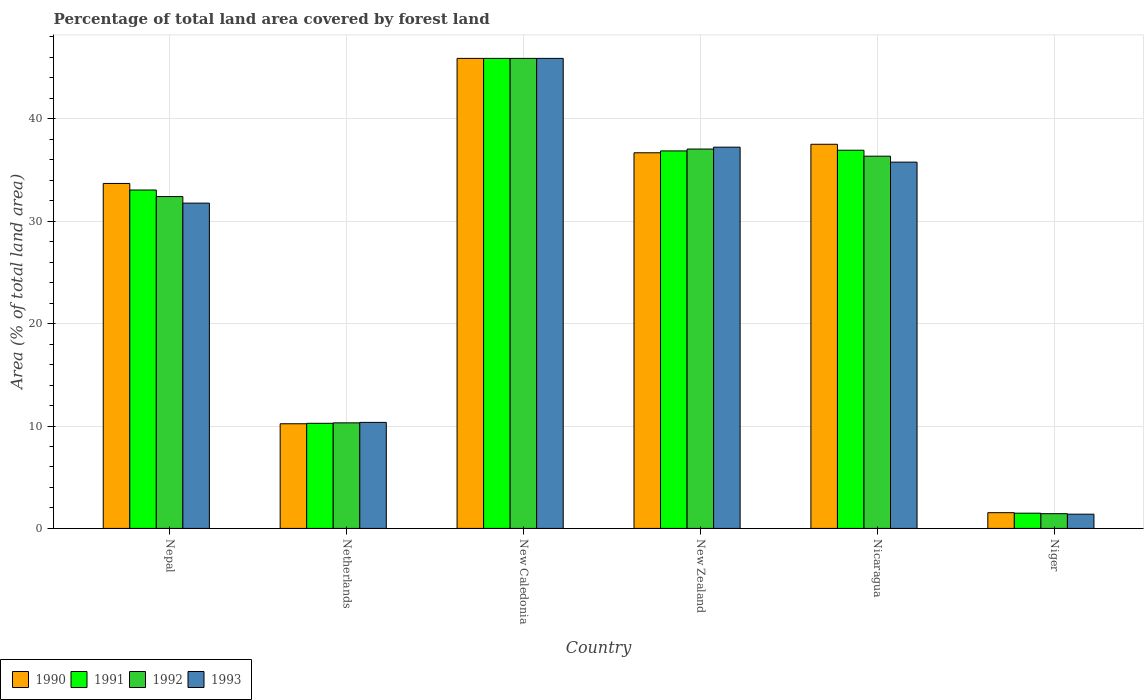How many different coloured bars are there?
Give a very brief answer. 4. How many groups of bars are there?
Offer a very short reply. 6. Are the number of bars on each tick of the X-axis equal?
Offer a terse response. Yes. How many bars are there on the 5th tick from the right?
Offer a terse response. 4. What is the label of the 4th group of bars from the left?
Provide a short and direct response. New Zealand. What is the percentage of forest land in 1993 in Nepal?
Your response must be concise. 31.76. Across all countries, what is the maximum percentage of forest land in 1992?
Your answer should be very brief. 45.9. Across all countries, what is the minimum percentage of forest land in 1992?
Offer a terse response. 1.44. In which country was the percentage of forest land in 1992 maximum?
Make the answer very short. New Caledonia. In which country was the percentage of forest land in 1990 minimum?
Your response must be concise. Niger. What is the total percentage of forest land in 1992 in the graph?
Keep it short and to the point. 163.44. What is the difference between the percentage of forest land in 1991 in Netherlands and that in New Caledonia?
Provide a succinct answer. -35.63. What is the difference between the percentage of forest land in 1990 in Nepal and the percentage of forest land in 1992 in New Caledonia?
Offer a terse response. -12.21. What is the average percentage of forest land in 1992 per country?
Ensure brevity in your answer.  27.24. What is the ratio of the percentage of forest land in 1990 in Netherlands to that in Niger?
Keep it short and to the point. 6.66. Is the percentage of forest land in 1991 in New Zealand less than that in Nicaragua?
Offer a terse response. Yes. Is the difference between the percentage of forest land in 1991 in Nepal and New Zealand greater than the difference between the percentage of forest land in 1993 in Nepal and New Zealand?
Keep it short and to the point. Yes. What is the difference between the highest and the second highest percentage of forest land in 1991?
Your answer should be very brief. -8.97. What is the difference between the highest and the lowest percentage of forest land in 1990?
Make the answer very short. 44.36. Is the sum of the percentage of forest land in 1992 in New Caledonia and Niger greater than the maximum percentage of forest land in 1993 across all countries?
Provide a succinct answer. Yes. Is it the case that in every country, the sum of the percentage of forest land in 1991 and percentage of forest land in 1990 is greater than the sum of percentage of forest land in 1993 and percentage of forest land in 1992?
Make the answer very short. No. What does the 2nd bar from the right in New Zealand represents?
Your answer should be compact. 1992. Is it the case that in every country, the sum of the percentage of forest land in 1992 and percentage of forest land in 1991 is greater than the percentage of forest land in 1990?
Keep it short and to the point. Yes. Are all the bars in the graph horizontal?
Your answer should be compact. No. How many countries are there in the graph?
Ensure brevity in your answer.  6. How are the legend labels stacked?
Offer a terse response. Horizontal. What is the title of the graph?
Provide a succinct answer. Percentage of total land area covered by forest land. Does "1962" appear as one of the legend labels in the graph?
Ensure brevity in your answer.  No. What is the label or title of the X-axis?
Provide a short and direct response. Country. What is the label or title of the Y-axis?
Provide a succinct answer. Area (% of total land area). What is the Area (% of total land area) of 1990 in Nepal?
Offer a terse response. 33.69. What is the Area (% of total land area) of 1991 in Nepal?
Your answer should be very brief. 33.04. What is the Area (% of total land area) in 1992 in Nepal?
Offer a terse response. 32.4. What is the Area (% of total land area) of 1993 in Nepal?
Provide a short and direct response. 31.76. What is the Area (% of total land area) in 1990 in Netherlands?
Keep it short and to the point. 10.22. What is the Area (% of total land area) of 1991 in Netherlands?
Give a very brief answer. 10.26. What is the Area (% of total land area) of 1992 in Netherlands?
Provide a short and direct response. 10.31. What is the Area (% of total land area) of 1993 in Netherlands?
Provide a succinct answer. 10.35. What is the Area (% of total land area) in 1990 in New Caledonia?
Provide a short and direct response. 45.9. What is the Area (% of total land area) in 1991 in New Caledonia?
Offer a very short reply. 45.9. What is the Area (% of total land area) in 1992 in New Caledonia?
Ensure brevity in your answer.  45.9. What is the Area (% of total land area) in 1993 in New Caledonia?
Your response must be concise. 45.9. What is the Area (% of total land area) of 1990 in New Zealand?
Offer a very short reply. 36.68. What is the Area (% of total land area) of 1991 in New Zealand?
Your answer should be compact. 36.86. What is the Area (% of total land area) in 1992 in New Zealand?
Offer a terse response. 37.04. What is the Area (% of total land area) of 1993 in New Zealand?
Your response must be concise. 37.23. What is the Area (% of total land area) in 1990 in Nicaragua?
Offer a terse response. 37.51. What is the Area (% of total land area) of 1991 in Nicaragua?
Ensure brevity in your answer.  36.93. What is the Area (% of total land area) of 1992 in Nicaragua?
Give a very brief answer. 36.35. What is the Area (% of total land area) of 1993 in Nicaragua?
Keep it short and to the point. 35.77. What is the Area (% of total land area) of 1990 in Niger?
Your answer should be compact. 1.54. What is the Area (% of total land area) of 1991 in Niger?
Offer a terse response. 1.49. What is the Area (% of total land area) in 1992 in Niger?
Provide a succinct answer. 1.44. What is the Area (% of total land area) of 1993 in Niger?
Your answer should be very brief. 1.39. Across all countries, what is the maximum Area (% of total land area) of 1990?
Give a very brief answer. 45.9. Across all countries, what is the maximum Area (% of total land area) of 1991?
Offer a terse response. 45.9. Across all countries, what is the maximum Area (% of total land area) of 1992?
Keep it short and to the point. 45.9. Across all countries, what is the maximum Area (% of total land area) in 1993?
Your response must be concise. 45.9. Across all countries, what is the minimum Area (% of total land area) of 1990?
Offer a very short reply. 1.54. Across all countries, what is the minimum Area (% of total land area) in 1991?
Keep it short and to the point. 1.49. Across all countries, what is the minimum Area (% of total land area) in 1992?
Make the answer very short. 1.44. Across all countries, what is the minimum Area (% of total land area) in 1993?
Provide a short and direct response. 1.39. What is the total Area (% of total land area) in 1990 in the graph?
Offer a very short reply. 165.53. What is the total Area (% of total land area) in 1991 in the graph?
Your answer should be very brief. 164.48. What is the total Area (% of total land area) in 1992 in the graph?
Give a very brief answer. 163.44. What is the total Area (% of total land area) of 1993 in the graph?
Your answer should be compact. 162.39. What is the difference between the Area (% of total land area) of 1990 in Nepal and that in Netherlands?
Offer a very short reply. 23.47. What is the difference between the Area (% of total land area) in 1991 in Nepal and that in Netherlands?
Provide a succinct answer. 22.78. What is the difference between the Area (% of total land area) of 1992 in Nepal and that in Netherlands?
Provide a short and direct response. 22.09. What is the difference between the Area (% of total land area) of 1993 in Nepal and that in Netherlands?
Offer a very short reply. 21.41. What is the difference between the Area (% of total land area) in 1990 in Nepal and that in New Caledonia?
Your answer should be very brief. -12.21. What is the difference between the Area (% of total land area) in 1991 in Nepal and that in New Caledonia?
Your response must be concise. -12.85. What is the difference between the Area (% of total land area) in 1992 in Nepal and that in New Caledonia?
Give a very brief answer. -13.49. What is the difference between the Area (% of total land area) of 1993 in Nepal and that in New Caledonia?
Provide a short and direct response. -14.14. What is the difference between the Area (% of total land area) of 1990 in Nepal and that in New Zealand?
Keep it short and to the point. -2.99. What is the difference between the Area (% of total land area) of 1991 in Nepal and that in New Zealand?
Your answer should be compact. -3.82. What is the difference between the Area (% of total land area) of 1992 in Nepal and that in New Zealand?
Ensure brevity in your answer.  -4.64. What is the difference between the Area (% of total land area) of 1993 in Nepal and that in New Zealand?
Keep it short and to the point. -5.47. What is the difference between the Area (% of total land area) of 1990 in Nepal and that in Nicaragua?
Ensure brevity in your answer.  -3.83. What is the difference between the Area (% of total land area) in 1991 in Nepal and that in Nicaragua?
Offer a terse response. -3.88. What is the difference between the Area (% of total land area) in 1992 in Nepal and that in Nicaragua?
Your response must be concise. -3.94. What is the difference between the Area (% of total land area) in 1993 in Nepal and that in Nicaragua?
Provide a succinct answer. -4. What is the difference between the Area (% of total land area) of 1990 in Nepal and that in Niger?
Offer a very short reply. 32.15. What is the difference between the Area (% of total land area) of 1991 in Nepal and that in Niger?
Ensure brevity in your answer.  31.56. What is the difference between the Area (% of total land area) in 1992 in Nepal and that in Niger?
Make the answer very short. 30.96. What is the difference between the Area (% of total land area) in 1993 in Nepal and that in Niger?
Make the answer very short. 30.37. What is the difference between the Area (% of total land area) in 1990 in Netherlands and that in New Caledonia?
Offer a very short reply. -35.68. What is the difference between the Area (% of total land area) in 1991 in Netherlands and that in New Caledonia?
Provide a succinct answer. -35.63. What is the difference between the Area (% of total land area) in 1992 in Netherlands and that in New Caledonia?
Your answer should be very brief. -35.59. What is the difference between the Area (% of total land area) in 1993 in Netherlands and that in New Caledonia?
Your response must be concise. -35.54. What is the difference between the Area (% of total land area) of 1990 in Netherlands and that in New Zealand?
Provide a succinct answer. -26.46. What is the difference between the Area (% of total land area) in 1991 in Netherlands and that in New Zealand?
Give a very brief answer. -26.6. What is the difference between the Area (% of total land area) in 1992 in Netherlands and that in New Zealand?
Keep it short and to the point. -26.74. What is the difference between the Area (% of total land area) in 1993 in Netherlands and that in New Zealand?
Ensure brevity in your answer.  -26.87. What is the difference between the Area (% of total land area) in 1990 in Netherlands and that in Nicaragua?
Your response must be concise. -27.29. What is the difference between the Area (% of total land area) in 1991 in Netherlands and that in Nicaragua?
Your answer should be very brief. -26.67. What is the difference between the Area (% of total land area) of 1992 in Netherlands and that in Nicaragua?
Offer a very short reply. -26.04. What is the difference between the Area (% of total land area) in 1993 in Netherlands and that in Nicaragua?
Your response must be concise. -25.41. What is the difference between the Area (% of total land area) in 1990 in Netherlands and that in Niger?
Ensure brevity in your answer.  8.68. What is the difference between the Area (% of total land area) of 1991 in Netherlands and that in Niger?
Offer a terse response. 8.78. What is the difference between the Area (% of total land area) in 1992 in Netherlands and that in Niger?
Ensure brevity in your answer.  8.87. What is the difference between the Area (% of total land area) of 1993 in Netherlands and that in Niger?
Give a very brief answer. 8.96. What is the difference between the Area (% of total land area) of 1990 in New Caledonia and that in New Zealand?
Keep it short and to the point. 9.22. What is the difference between the Area (% of total land area) of 1991 in New Caledonia and that in New Zealand?
Your response must be concise. 9.04. What is the difference between the Area (% of total land area) in 1992 in New Caledonia and that in New Zealand?
Give a very brief answer. 8.85. What is the difference between the Area (% of total land area) in 1993 in New Caledonia and that in New Zealand?
Provide a short and direct response. 8.67. What is the difference between the Area (% of total land area) of 1990 in New Caledonia and that in Nicaragua?
Provide a short and direct response. 8.39. What is the difference between the Area (% of total land area) of 1991 in New Caledonia and that in Nicaragua?
Your answer should be very brief. 8.97. What is the difference between the Area (% of total land area) of 1992 in New Caledonia and that in Nicaragua?
Give a very brief answer. 9.55. What is the difference between the Area (% of total land area) in 1993 in New Caledonia and that in Nicaragua?
Give a very brief answer. 10.13. What is the difference between the Area (% of total land area) in 1990 in New Caledonia and that in Niger?
Ensure brevity in your answer.  44.36. What is the difference between the Area (% of total land area) in 1991 in New Caledonia and that in Niger?
Make the answer very short. 44.41. What is the difference between the Area (% of total land area) in 1992 in New Caledonia and that in Niger?
Ensure brevity in your answer.  44.46. What is the difference between the Area (% of total land area) of 1993 in New Caledonia and that in Niger?
Keep it short and to the point. 44.51. What is the difference between the Area (% of total land area) of 1990 in New Zealand and that in Nicaragua?
Provide a short and direct response. -0.83. What is the difference between the Area (% of total land area) of 1991 in New Zealand and that in Nicaragua?
Ensure brevity in your answer.  -0.07. What is the difference between the Area (% of total land area) of 1992 in New Zealand and that in Nicaragua?
Offer a very short reply. 0.7. What is the difference between the Area (% of total land area) of 1993 in New Zealand and that in Nicaragua?
Give a very brief answer. 1.46. What is the difference between the Area (% of total land area) in 1990 in New Zealand and that in Niger?
Provide a succinct answer. 35.14. What is the difference between the Area (% of total land area) of 1991 in New Zealand and that in Niger?
Your response must be concise. 35.38. What is the difference between the Area (% of total land area) of 1992 in New Zealand and that in Niger?
Offer a terse response. 35.61. What is the difference between the Area (% of total land area) in 1993 in New Zealand and that in Niger?
Give a very brief answer. 35.84. What is the difference between the Area (% of total land area) in 1990 in Nicaragua and that in Niger?
Your answer should be compact. 35.97. What is the difference between the Area (% of total land area) in 1991 in Nicaragua and that in Niger?
Provide a short and direct response. 35.44. What is the difference between the Area (% of total land area) in 1992 in Nicaragua and that in Niger?
Your response must be concise. 34.91. What is the difference between the Area (% of total land area) of 1993 in Nicaragua and that in Niger?
Your answer should be compact. 34.38. What is the difference between the Area (% of total land area) in 1990 in Nepal and the Area (% of total land area) in 1991 in Netherlands?
Offer a very short reply. 23.42. What is the difference between the Area (% of total land area) of 1990 in Nepal and the Area (% of total land area) of 1992 in Netherlands?
Make the answer very short. 23.38. What is the difference between the Area (% of total land area) of 1990 in Nepal and the Area (% of total land area) of 1993 in Netherlands?
Provide a short and direct response. 23.33. What is the difference between the Area (% of total land area) in 1991 in Nepal and the Area (% of total land area) in 1992 in Netherlands?
Keep it short and to the point. 22.74. What is the difference between the Area (% of total land area) in 1991 in Nepal and the Area (% of total land area) in 1993 in Netherlands?
Give a very brief answer. 22.69. What is the difference between the Area (% of total land area) of 1992 in Nepal and the Area (% of total land area) of 1993 in Netherlands?
Ensure brevity in your answer.  22.05. What is the difference between the Area (% of total land area) of 1990 in Nepal and the Area (% of total land area) of 1991 in New Caledonia?
Your answer should be compact. -12.21. What is the difference between the Area (% of total land area) of 1990 in Nepal and the Area (% of total land area) of 1992 in New Caledonia?
Give a very brief answer. -12.21. What is the difference between the Area (% of total land area) in 1990 in Nepal and the Area (% of total land area) in 1993 in New Caledonia?
Ensure brevity in your answer.  -12.21. What is the difference between the Area (% of total land area) in 1991 in Nepal and the Area (% of total land area) in 1992 in New Caledonia?
Your answer should be very brief. -12.85. What is the difference between the Area (% of total land area) in 1991 in Nepal and the Area (% of total land area) in 1993 in New Caledonia?
Make the answer very short. -12.85. What is the difference between the Area (% of total land area) of 1992 in Nepal and the Area (% of total land area) of 1993 in New Caledonia?
Your answer should be very brief. -13.49. What is the difference between the Area (% of total land area) in 1990 in Nepal and the Area (% of total land area) in 1991 in New Zealand?
Make the answer very short. -3.18. What is the difference between the Area (% of total land area) in 1990 in Nepal and the Area (% of total land area) in 1992 in New Zealand?
Give a very brief answer. -3.36. What is the difference between the Area (% of total land area) of 1990 in Nepal and the Area (% of total land area) of 1993 in New Zealand?
Provide a short and direct response. -3.54. What is the difference between the Area (% of total land area) of 1991 in Nepal and the Area (% of total land area) of 1992 in New Zealand?
Your answer should be very brief. -4. What is the difference between the Area (% of total land area) of 1991 in Nepal and the Area (% of total land area) of 1993 in New Zealand?
Offer a very short reply. -4.18. What is the difference between the Area (% of total land area) of 1992 in Nepal and the Area (% of total land area) of 1993 in New Zealand?
Give a very brief answer. -4.82. What is the difference between the Area (% of total land area) in 1990 in Nepal and the Area (% of total land area) in 1991 in Nicaragua?
Make the answer very short. -3.24. What is the difference between the Area (% of total land area) in 1990 in Nepal and the Area (% of total land area) in 1992 in Nicaragua?
Give a very brief answer. -2.66. What is the difference between the Area (% of total land area) in 1990 in Nepal and the Area (% of total land area) in 1993 in Nicaragua?
Make the answer very short. -2.08. What is the difference between the Area (% of total land area) of 1991 in Nepal and the Area (% of total land area) of 1992 in Nicaragua?
Offer a very short reply. -3.3. What is the difference between the Area (% of total land area) of 1991 in Nepal and the Area (% of total land area) of 1993 in Nicaragua?
Give a very brief answer. -2.72. What is the difference between the Area (% of total land area) in 1992 in Nepal and the Area (% of total land area) in 1993 in Nicaragua?
Offer a terse response. -3.36. What is the difference between the Area (% of total land area) of 1990 in Nepal and the Area (% of total land area) of 1991 in Niger?
Your response must be concise. 32.2. What is the difference between the Area (% of total land area) of 1990 in Nepal and the Area (% of total land area) of 1992 in Niger?
Give a very brief answer. 32.25. What is the difference between the Area (% of total land area) of 1990 in Nepal and the Area (% of total land area) of 1993 in Niger?
Make the answer very short. 32.3. What is the difference between the Area (% of total land area) of 1991 in Nepal and the Area (% of total land area) of 1992 in Niger?
Ensure brevity in your answer.  31.61. What is the difference between the Area (% of total land area) of 1991 in Nepal and the Area (% of total land area) of 1993 in Niger?
Provide a short and direct response. 31.65. What is the difference between the Area (% of total land area) in 1992 in Nepal and the Area (% of total land area) in 1993 in Niger?
Provide a short and direct response. 31.01. What is the difference between the Area (% of total land area) of 1990 in Netherlands and the Area (% of total land area) of 1991 in New Caledonia?
Keep it short and to the point. -35.68. What is the difference between the Area (% of total land area) in 1990 in Netherlands and the Area (% of total land area) in 1992 in New Caledonia?
Offer a very short reply. -35.68. What is the difference between the Area (% of total land area) in 1990 in Netherlands and the Area (% of total land area) in 1993 in New Caledonia?
Your answer should be very brief. -35.68. What is the difference between the Area (% of total land area) of 1991 in Netherlands and the Area (% of total land area) of 1992 in New Caledonia?
Your answer should be compact. -35.63. What is the difference between the Area (% of total land area) of 1991 in Netherlands and the Area (% of total land area) of 1993 in New Caledonia?
Offer a very short reply. -35.63. What is the difference between the Area (% of total land area) of 1992 in Netherlands and the Area (% of total land area) of 1993 in New Caledonia?
Provide a short and direct response. -35.59. What is the difference between the Area (% of total land area) of 1990 in Netherlands and the Area (% of total land area) of 1991 in New Zealand?
Your response must be concise. -26.64. What is the difference between the Area (% of total land area) of 1990 in Netherlands and the Area (% of total land area) of 1992 in New Zealand?
Ensure brevity in your answer.  -26.83. What is the difference between the Area (% of total land area) in 1990 in Netherlands and the Area (% of total land area) in 1993 in New Zealand?
Keep it short and to the point. -27.01. What is the difference between the Area (% of total land area) in 1991 in Netherlands and the Area (% of total land area) in 1992 in New Zealand?
Keep it short and to the point. -26.78. What is the difference between the Area (% of total land area) in 1991 in Netherlands and the Area (% of total land area) in 1993 in New Zealand?
Offer a very short reply. -26.96. What is the difference between the Area (% of total land area) of 1992 in Netherlands and the Area (% of total land area) of 1993 in New Zealand?
Keep it short and to the point. -26.92. What is the difference between the Area (% of total land area) in 1990 in Netherlands and the Area (% of total land area) in 1991 in Nicaragua?
Your response must be concise. -26.71. What is the difference between the Area (% of total land area) in 1990 in Netherlands and the Area (% of total land area) in 1992 in Nicaragua?
Provide a short and direct response. -26.13. What is the difference between the Area (% of total land area) of 1990 in Netherlands and the Area (% of total land area) of 1993 in Nicaragua?
Give a very brief answer. -25.55. What is the difference between the Area (% of total land area) in 1991 in Netherlands and the Area (% of total land area) in 1992 in Nicaragua?
Offer a terse response. -26.08. What is the difference between the Area (% of total land area) of 1991 in Netherlands and the Area (% of total land area) of 1993 in Nicaragua?
Provide a short and direct response. -25.5. What is the difference between the Area (% of total land area) of 1992 in Netherlands and the Area (% of total land area) of 1993 in Nicaragua?
Make the answer very short. -25.46. What is the difference between the Area (% of total land area) of 1990 in Netherlands and the Area (% of total land area) of 1991 in Niger?
Your answer should be very brief. 8.73. What is the difference between the Area (% of total land area) of 1990 in Netherlands and the Area (% of total land area) of 1992 in Niger?
Provide a short and direct response. 8.78. What is the difference between the Area (% of total land area) in 1990 in Netherlands and the Area (% of total land area) in 1993 in Niger?
Give a very brief answer. 8.83. What is the difference between the Area (% of total land area) in 1991 in Netherlands and the Area (% of total land area) in 1992 in Niger?
Your answer should be compact. 8.83. What is the difference between the Area (% of total land area) in 1991 in Netherlands and the Area (% of total land area) in 1993 in Niger?
Offer a terse response. 8.87. What is the difference between the Area (% of total land area) of 1992 in Netherlands and the Area (% of total land area) of 1993 in Niger?
Your answer should be compact. 8.92. What is the difference between the Area (% of total land area) of 1990 in New Caledonia and the Area (% of total land area) of 1991 in New Zealand?
Your answer should be very brief. 9.04. What is the difference between the Area (% of total land area) in 1990 in New Caledonia and the Area (% of total land area) in 1992 in New Zealand?
Offer a very short reply. 8.85. What is the difference between the Area (% of total land area) of 1990 in New Caledonia and the Area (% of total land area) of 1993 in New Zealand?
Your answer should be compact. 8.67. What is the difference between the Area (% of total land area) in 1991 in New Caledonia and the Area (% of total land area) in 1992 in New Zealand?
Provide a succinct answer. 8.85. What is the difference between the Area (% of total land area) in 1991 in New Caledonia and the Area (% of total land area) in 1993 in New Zealand?
Your response must be concise. 8.67. What is the difference between the Area (% of total land area) of 1992 in New Caledonia and the Area (% of total land area) of 1993 in New Zealand?
Give a very brief answer. 8.67. What is the difference between the Area (% of total land area) in 1990 in New Caledonia and the Area (% of total land area) in 1991 in Nicaragua?
Ensure brevity in your answer.  8.97. What is the difference between the Area (% of total land area) in 1990 in New Caledonia and the Area (% of total land area) in 1992 in Nicaragua?
Your answer should be compact. 9.55. What is the difference between the Area (% of total land area) of 1990 in New Caledonia and the Area (% of total land area) of 1993 in Nicaragua?
Your response must be concise. 10.13. What is the difference between the Area (% of total land area) of 1991 in New Caledonia and the Area (% of total land area) of 1992 in Nicaragua?
Provide a succinct answer. 9.55. What is the difference between the Area (% of total land area) in 1991 in New Caledonia and the Area (% of total land area) in 1993 in Nicaragua?
Offer a very short reply. 10.13. What is the difference between the Area (% of total land area) of 1992 in New Caledonia and the Area (% of total land area) of 1993 in Nicaragua?
Your answer should be compact. 10.13. What is the difference between the Area (% of total land area) in 1990 in New Caledonia and the Area (% of total land area) in 1991 in Niger?
Give a very brief answer. 44.41. What is the difference between the Area (% of total land area) in 1990 in New Caledonia and the Area (% of total land area) in 1992 in Niger?
Offer a very short reply. 44.46. What is the difference between the Area (% of total land area) in 1990 in New Caledonia and the Area (% of total land area) in 1993 in Niger?
Offer a very short reply. 44.51. What is the difference between the Area (% of total land area) in 1991 in New Caledonia and the Area (% of total land area) in 1992 in Niger?
Your answer should be very brief. 44.46. What is the difference between the Area (% of total land area) in 1991 in New Caledonia and the Area (% of total land area) in 1993 in Niger?
Give a very brief answer. 44.51. What is the difference between the Area (% of total land area) of 1992 in New Caledonia and the Area (% of total land area) of 1993 in Niger?
Your answer should be very brief. 44.51. What is the difference between the Area (% of total land area) of 1990 in New Zealand and the Area (% of total land area) of 1991 in Nicaragua?
Give a very brief answer. -0.25. What is the difference between the Area (% of total land area) of 1990 in New Zealand and the Area (% of total land area) of 1992 in Nicaragua?
Your response must be concise. 0.33. What is the difference between the Area (% of total land area) in 1990 in New Zealand and the Area (% of total land area) in 1993 in Nicaragua?
Ensure brevity in your answer.  0.91. What is the difference between the Area (% of total land area) of 1991 in New Zealand and the Area (% of total land area) of 1992 in Nicaragua?
Make the answer very short. 0.51. What is the difference between the Area (% of total land area) of 1991 in New Zealand and the Area (% of total land area) of 1993 in Nicaragua?
Provide a succinct answer. 1.1. What is the difference between the Area (% of total land area) in 1992 in New Zealand and the Area (% of total land area) in 1993 in Nicaragua?
Ensure brevity in your answer.  1.28. What is the difference between the Area (% of total land area) of 1990 in New Zealand and the Area (% of total land area) of 1991 in Niger?
Ensure brevity in your answer.  35.19. What is the difference between the Area (% of total land area) of 1990 in New Zealand and the Area (% of total land area) of 1992 in Niger?
Give a very brief answer. 35.24. What is the difference between the Area (% of total land area) in 1990 in New Zealand and the Area (% of total land area) in 1993 in Niger?
Keep it short and to the point. 35.29. What is the difference between the Area (% of total land area) in 1991 in New Zealand and the Area (% of total land area) in 1992 in Niger?
Provide a succinct answer. 35.42. What is the difference between the Area (% of total land area) in 1991 in New Zealand and the Area (% of total land area) in 1993 in Niger?
Provide a short and direct response. 35.47. What is the difference between the Area (% of total land area) in 1992 in New Zealand and the Area (% of total land area) in 1993 in Niger?
Provide a succinct answer. 35.66. What is the difference between the Area (% of total land area) of 1990 in Nicaragua and the Area (% of total land area) of 1991 in Niger?
Your answer should be compact. 36.02. What is the difference between the Area (% of total land area) of 1990 in Nicaragua and the Area (% of total land area) of 1992 in Niger?
Your answer should be very brief. 36.07. What is the difference between the Area (% of total land area) of 1990 in Nicaragua and the Area (% of total land area) of 1993 in Niger?
Offer a very short reply. 36.12. What is the difference between the Area (% of total land area) in 1991 in Nicaragua and the Area (% of total land area) in 1992 in Niger?
Make the answer very short. 35.49. What is the difference between the Area (% of total land area) in 1991 in Nicaragua and the Area (% of total land area) in 1993 in Niger?
Your response must be concise. 35.54. What is the difference between the Area (% of total land area) of 1992 in Nicaragua and the Area (% of total land area) of 1993 in Niger?
Your answer should be very brief. 34.96. What is the average Area (% of total land area) of 1990 per country?
Your answer should be compact. 27.59. What is the average Area (% of total land area) in 1991 per country?
Provide a succinct answer. 27.41. What is the average Area (% of total land area) of 1992 per country?
Your response must be concise. 27.24. What is the average Area (% of total land area) of 1993 per country?
Your answer should be compact. 27.07. What is the difference between the Area (% of total land area) of 1990 and Area (% of total land area) of 1991 in Nepal?
Provide a succinct answer. 0.64. What is the difference between the Area (% of total land area) of 1990 and Area (% of total land area) of 1992 in Nepal?
Provide a short and direct response. 1.28. What is the difference between the Area (% of total land area) in 1990 and Area (% of total land area) in 1993 in Nepal?
Give a very brief answer. 1.92. What is the difference between the Area (% of total land area) of 1991 and Area (% of total land area) of 1992 in Nepal?
Make the answer very short. 0.64. What is the difference between the Area (% of total land area) in 1991 and Area (% of total land area) in 1993 in Nepal?
Your answer should be very brief. 1.28. What is the difference between the Area (% of total land area) in 1992 and Area (% of total land area) in 1993 in Nepal?
Provide a succinct answer. 0.64. What is the difference between the Area (% of total land area) in 1990 and Area (% of total land area) in 1991 in Netherlands?
Keep it short and to the point. -0.04. What is the difference between the Area (% of total land area) in 1990 and Area (% of total land area) in 1992 in Netherlands?
Provide a short and direct response. -0.09. What is the difference between the Area (% of total land area) in 1990 and Area (% of total land area) in 1993 in Netherlands?
Give a very brief answer. -0.13. What is the difference between the Area (% of total land area) of 1991 and Area (% of total land area) of 1992 in Netherlands?
Ensure brevity in your answer.  -0.04. What is the difference between the Area (% of total land area) in 1991 and Area (% of total land area) in 1993 in Netherlands?
Make the answer very short. -0.09. What is the difference between the Area (% of total land area) in 1992 and Area (% of total land area) in 1993 in Netherlands?
Your answer should be very brief. -0.04. What is the difference between the Area (% of total land area) of 1990 and Area (% of total land area) of 1992 in New Caledonia?
Give a very brief answer. 0. What is the difference between the Area (% of total land area) of 1990 and Area (% of total land area) of 1993 in New Caledonia?
Your response must be concise. 0. What is the difference between the Area (% of total land area) in 1991 and Area (% of total land area) in 1992 in New Caledonia?
Keep it short and to the point. 0. What is the difference between the Area (% of total land area) of 1991 and Area (% of total land area) of 1993 in New Caledonia?
Offer a very short reply. 0. What is the difference between the Area (% of total land area) in 1992 and Area (% of total land area) in 1993 in New Caledonia?
Provide a short and direct response. 0. What is the difference between the Area (% of total land area) in 1990 and Area (% of total land area) in 1991 in New Zealand?
Your response must be concise. -0.18. What is the difference between the Area (% of total land area) in 1990 and Area (% of total land area) in 1992 in New Zealand?
Offer a terse response. -0.37. What is the difference between the Area (% of total land area) of 1990 and Area (% of total land area) of 1993 in New Zealand?
Keep it short and to the point. -0.55. What is the difference between the Area (% of total land area) of 1991 and Area (% of total land area) of 1992 in New Zealand?
Offer a terse response. -0.18. What is the difference between the Area (% of total land area) in 1991 and Area (% of total land area) in 1993 in New Zealand?
Provide a short and direct response. -0.37. What is the difference between the Area (% of total land area) of 1992 and Area (% of total land area) of 1993 in New Zealand?
Offer a very short reply. -0.18. What is the difference between the Area (% of total land area) of 1990 and Area (% of total land area) of 1991 in Nicaragua?
Provide a succinct answer. 0.58. What is the difference between the Area (% of total land area) of 1990 and Area (% of total land area) of 1992 in Nicaragua?
Provide a short and direct response. 1.16. What is the difference between the Area (% of total land area) of 1990 and Area (% of total land area) of 1993 in Nicaragua?
Keep it short and to the point. 1.75. What is the difference between the Area (% of total land area) of 1991 and Area (% of total land area) of 1992 in Nicaragua?
Your answer should be very brief. 0.58. What is the difference between the Area (% of total land area) in 1991 and Area (% of total land area) in 1993 in Nicaragua?
Ensure brevity in your answer.  1.16. What is the difference between the Area (% of total land area) of 1992 and Area (% of total land area) of 1993 in Nicaragua?
Your answer should be very brief. 0.58. What is the difference between the Area (% of total land area) of 1990 and Area (% of total land area) of 1991 in Niger?
Your response must be concise. 0.05. What is the difference between the Area (% of total land area) of 1990 and Area (% of total land area) of 1992 in Niger?
Provide a succinct answer. 0.1. What is the difference between the Area (% of total land area) in 1990 and Area (% of total land area) in 1993 in Niger?
Provide a short and direct response. 0.15. What is the difference between the Area (% of total land area) in 1991 and Area (% of total land area) in 1992 in Niger?
Offer a very short reply. 0.05. What is the difference between the Area (% of total land area) of 1991 and Area (% of total land area) of 1993 in Niger?
Your response must be concise. 0.1. What is the difference between the Area (% of total land area) in 1992 and Area (% of total land area) in 1993 in Niger?
Ensure brevity in your answer.  0.05. What is the ratio of the Area (% of total land area) in 1990 in Nepal to that in Netherlands?
Give a very brief answer. 3.3. What is the ratio of the Area (% of total land area) in 1991 in Nepal to that in Netherlands?
Give a very brief answer. 3.22. What is the ratio of the Area (% of total land area) of 1992 in Nepal to that in Netherlands?
Offer a very short reply. 3.14. What is the ratio of the Area (% of total land area) in 1993 in Nepal to that in Netherlands?
Offer a terse response. 3.07. What is the ratio of the Area (% of total land area) in 1990 in Nepal to that in New Caledonia?
Keep it short and to the point. 0.73. What is the ratio of the Area (% of total land area) of 1991 in Nepal to that in New Caledonia?
Your answer should be very brief. 0.72. What is the ratio of the Area (% of total land area) in 1992 in Nepal to that in New Caledonia?
Make the answer very short. 0.71. What is the ratio of the Area (% of total land area) of 1993 in Nepal to that in New Caledonia?
Make the answer very short. 0.69. What is the ratio of the Area (% of total land area) of 1990 in Nepal to that in New Zealand?
Offer a very short reply. 0.92. What is the ratio of the Area (% of total land area) of 1991 in Nepal to that in New Zealand?
Your answer should be very brief. 0.9. What is the ratio of the Area (% of total land area) of 1992 in Nepal to that in New Zealand?
Offer a terse response. 0.87. What is the ratio of the Area (% of total land area) of 1993 in Nepal to that in New Zealand?
Provide a short and direct response. 0.85. What is the ratio of the Area (% of total land area) of 1990 in Nepal to that in Nicaragua?
Offer a very short reply. 0.9. What is the ratio of the Area (% of total land area) in 1991 in Nepal to that in Nicaragua?
Your answer should be very brief. 0.89. What is the ratio of the Area (% of total land area) of 1992 in Nepal to that in Nicaragua?
Offer a terse response. 0.89. What is the ratio of the Area (% of total land area) of 1993 in Nepal to that in Nicaragua?
Keep it short and to the point. 0.89. What is the ratio of the Area (% of total land area) in 1990 in Nepal to that in Niger?
Your answer should be very brief. 21.94. What is the ratio of the Area (% of total land area) of 1991 in Nepal to that in Niger?
Ensure brevity in your answer.  22.23. What is the ratio of the Area (% of total land area) of 1992 in Nepal to that in Niger?
Provide a short and direct response. 22.53. What is the ratio of the Area (% of total land area) of 1993 in Nepal to that in Niger?
Keep it short and to the point. 22.86. What is the ratio of the Area (% of total land area) of 1990 in Netherlands to that in New Caledonia?
Give a very brief answer. 0.22. What is the ratio of the Area (% of total land area) of 1991 in Netherlands to that in New Caledonia?
Provide a short and direct response. 0.22. What is the ratio of the Area (% of total land area) of 1992 in Netherlands to that in New Caledonia?
Your response must be concise. 0.22. What is the ratio of the Area (% of total land area) of 1993 in Netherlands to that in New Caledonia?
Offer a very short reply. 0.23. What is the ratio of the Area (% of total land area) in 1990 in Netherlands to that in New Zealand?
Ensure brevity in your answer.  0.28. What is the ratio of the Area (% of total land area) in 1991 in Netherlands to that in New Zealand?
Ensure brevity in your answer.  0.28. What is the ratio of the Area (% of total land area) in 1992 in Netherlands to that in New Zealand?
Offer a very short reply. 0.28. What is the ratio of the Area (% of total land area) in 1993 in Netherlands to that in New Zealand?
Your answer should be very brief. 0.28. What is the ratio of the Area (% of total land area) of 1990 in Netherlands to that in Nicaragua?
Provide a succinct answer. 0.27. What is the ratio of the Area (% of total land area) in 1991 in Netherlands to that in Nicaragua?
Ensure brevity in your answer.  0.28. What is the ratio of the Area (% of total land area) in 1992 in Netherlands to that in Nicaragua?
Ensure brevity in your answer.  0.28. What is the ratio of the Area (% of total land area) in 1993 in Netherlands to that in Nicaragua?
Give a very brief answer. 0.29. What is the ratio of the Area (% of total land area) of 1990 in Netherlands to that in Niger?
Keep it short and to the point. 6.66. What is the ratio of the Area (% of total land area) of 1991 in Netherlands to that in Niger?
Give a very brief answer. 6.9. What is the ratio of the Area (% of total land area) in 1992 in Netherlands to that in Niger?
Make the answer very short. 7.17. What is the ratio of the Area (% of total land area) in 1993 in Netherlands to that in Niger?
Provide a succinct answer. 7.45. What is the ratio of the Area (% of total land area) in 1990 in New Caledonia to that in New Zealand?
Offer a terse response. 1.25. What is the ratio of the Area (% of total land area) in 1991 in New Caledonia to that in New Zealand?
Make the answer very short. 1.25. What is the ratio of the Area (% of total land area) in 1992 in New Caledonia to that in New Zealand?
Provide a succinct answer. 1.24. What is the ratio of the Area (% of total land area) in 1993 in New Caledonia to that in New Zealand?
Your answer should be compact. 1.23. What is the ratio of the Area (% of total land area) of 1990 in New Caledonia to that in Nicaragua?
Your answer should be compact. 1.22. What is the ratio of the Area (% of total land area) in 1991 in New Caledonia to that in Nicaragua?
Provide a succinct answer. 1.24. What is the ratio of the Area (% of total land area) of 1992 in New Caledonia to that in Nicaragua?
Your answer should be compact. 1.26. What is the ratio of the Area (% of total land area) in 1993 in New Caledonia to that in Nicaragua?
Offer a terse response. 1.28. What is the ratio of the Area (% of total land area) in 1990 in New Caledonia to that in Niger?
Offer a terse response. 29.89. What is the ratio of the Area (% of total land area) in 1991 in New Caledonia to that in Niger?
Your answer should be very brief. 30.87. What is the ratio of the Area (% of total land area) of 1992 in New Caledonia to that in Niger?
Make the answer very short. 31.92. What is the ratio of the Area (% of total land area) of 1993 in New Caledonia to that in Niger?
Provide a succinct answer. 33.03. What is the ratio of the Area (% of total land area) in 1990 in New Zealand to that in Nicaragua?
Ensure brevity in your answer.  0.98. What is the ratio of the Area (% of total land area) in 1992 in New Zealand to that in Nicaragua?
Your answer should be very brief. 1.02. What is the ratio of the Area (% of total land area) in 1993 in New Zealand to that in Nicaragua?
Make the answer very short. 1.04. What is the ratio of the Area (% of total land area) in 1990 in New Zealand to that in Niger?
Provide a succinct answer. 23.89. What is the ratio of the Area (% of total land area) in 1991 in New Zealand to that in Niger?
Ensure brevity in your answer.  24.79. What is the ratio of the Area (% of total land area) in 1992 in New Zealand to that in Niger?
Offer a very short reply. 25.76. What is the ratio of the Area (% of total land area) of 1993 in New Zealand to that in Niger?
Make the answer very short. 26.79. What is the ratio of the Area (% of total land area) of 1990 in Nicaragua to that in Niger?
Keep it short and to the point. 24.43. What is the ratio of the Area (% of total land area) of 1991 in Nicaragua to that in Niger?
Offer a very short reply. 24.84. What is the ratio of the Area (% of total land area) of 1992 in Nicaragua to that in Niger?
Give a very brief answer. 25.27. What is the ratio of the Area (% of total land area) in 1993 in Nicaragua to that in Niger?
Provide a succinct answer. 25.74. What is the difference between the highest and the second highest Area (% of total land area) of 1990?
Your answer should be compact. 8.39. What is the difference between the highest and the second highest Area (% of total land area) of 1991?
Your answer should be very brief. 8.97. What is the difference between the highest and the second highest Area (% of total land area) in 1992?
Your answer should be compact. 8.85. What is the difference between the highest and the second highest Area (% of total land area) in 1993?
Your answer should be compact. 8.67. What is the difference between the highest and the lowest Area (% of total land area) in 1990?
Your answer should be very brief. 44.36. What is the difference between the highest and the lowest Area (% of total land area) in 1991?
Your answer should be compact. 44.41. What is the difference between the highest and the lowest Area (% of total land area) in 1992?
Offer a very short reply. 44.46. What is the difference between the highest and the lowest Area (% of total land area) of 1993?
Your response must be concise. 44.51. 